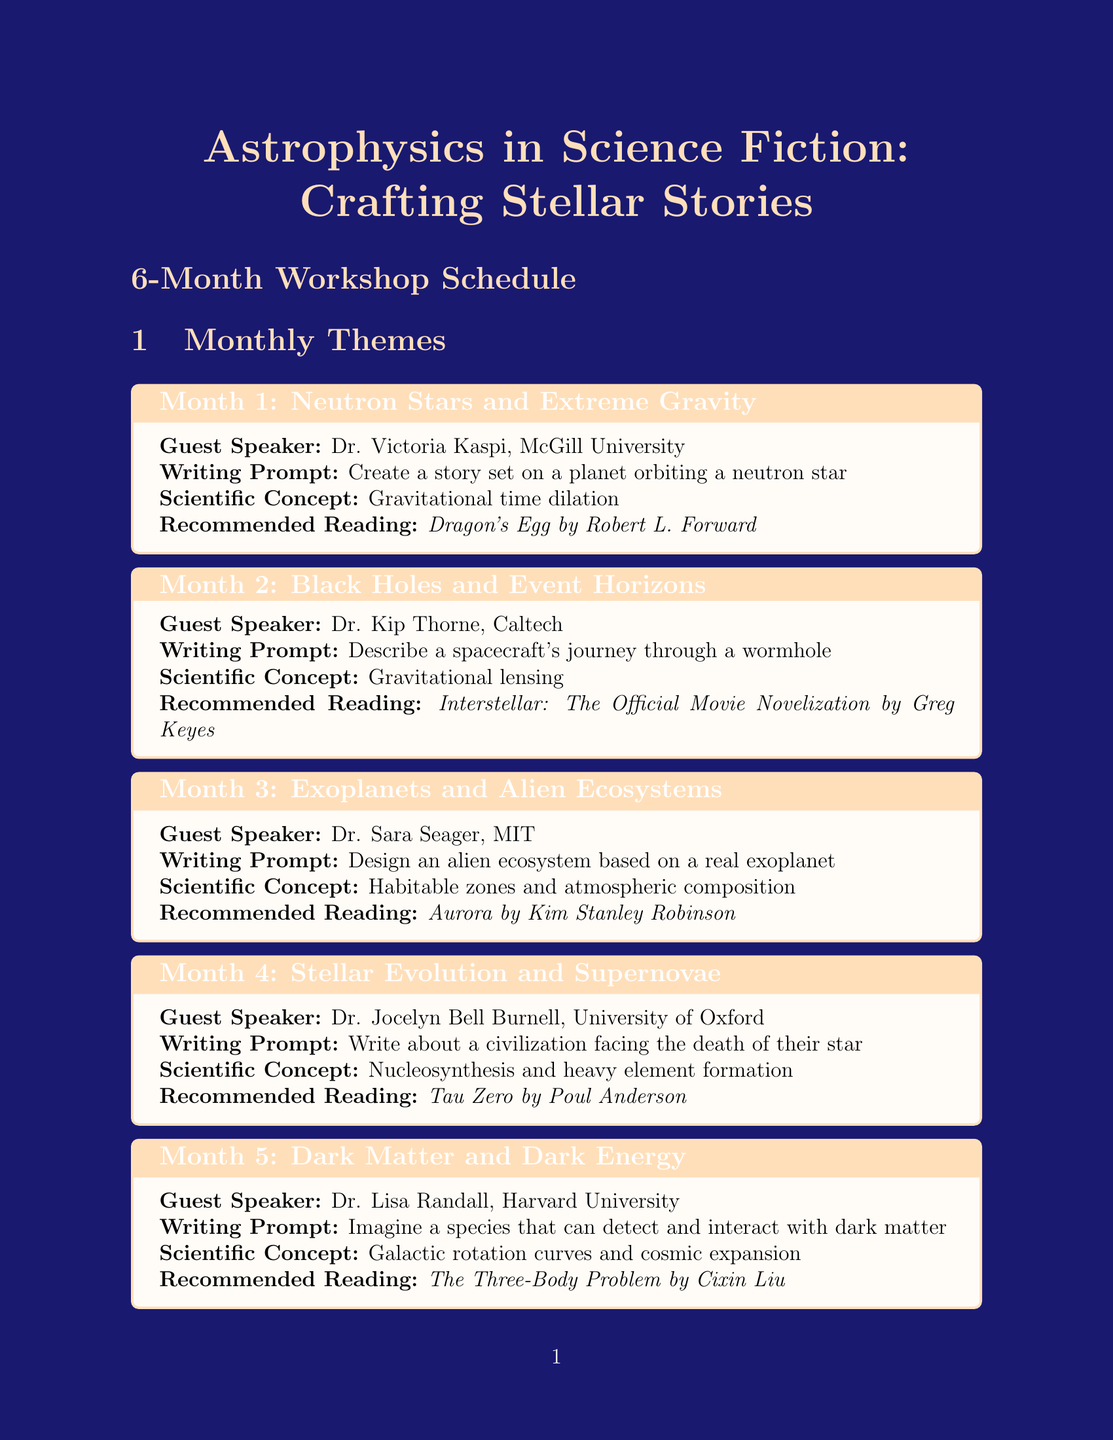What is the title of the workshop? The title is provided at the beginning of the document and serves as the main identifier of the workshop.
Answer: Astrophysics in Science Fiction: Crafting Stellar Stories Who is the guest speaker for Month 3? The guest speaker information is listed under each monthly theme specifically for Month 3.
Answer: Dr. Sara Seager, MIT What is the writing prompt for Month 5? Each monthly theme includes a specific writing prompt, which can be found directly under Month 5.
Answer: Imagine a species that can detect and interact with dark matter How many months does the workshop last? The workshop duration is stated in the document, specifically noted under the duration section.
Answer: 6 What scientific concept is explored in Month 1? The scientific concept for Month 1 is clearly listed under that month's theme for reference.
Answer: Gravitational time dilation What activity takes place in Week 3? Weekly activities are listed in a section of the document, revealing the specific focus of Week 3.
Answer: Scientific concept deep dive and brainstorming session What is the recommended reading for Month 4? The recommended readings are included with each monthly theme, corresponding to Month 4.
Answer: Tau Zero by Poul Anderson What is the final project description? The final project is outlined in a dedicated section of the document and includes what the participants need to produce at the end.
Answer: Compile a short story collection incorporating at least three astrophysical concepts explored during the workshop 